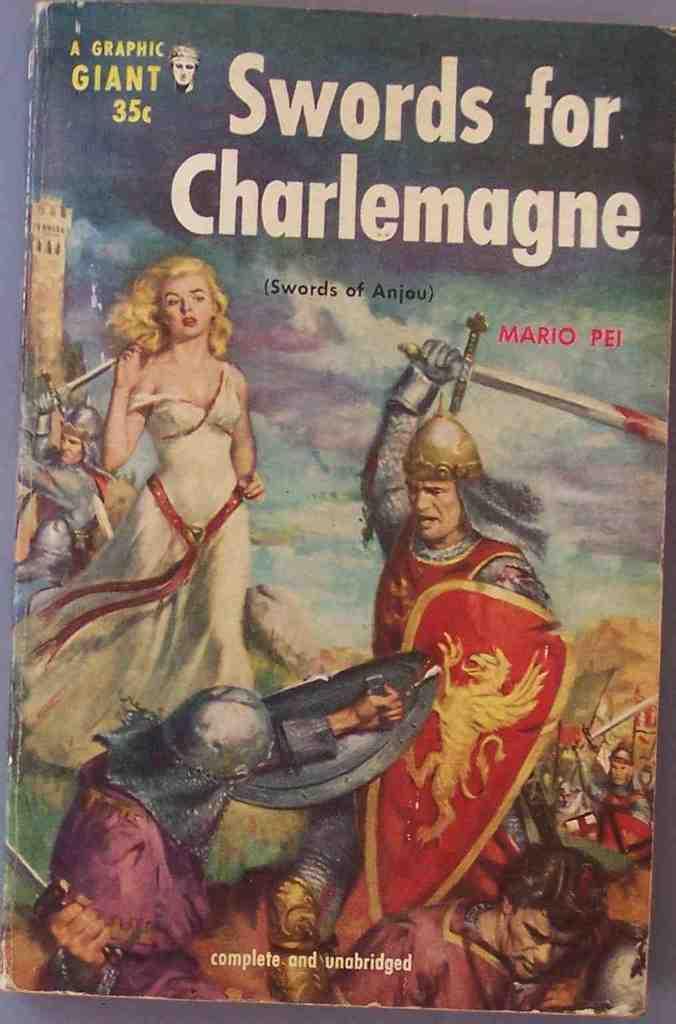How much did this book originally cost?
Your response must be concise. 35 cents. What is the title of this book?
Your answer should be compact. Swords for charlemagne. 